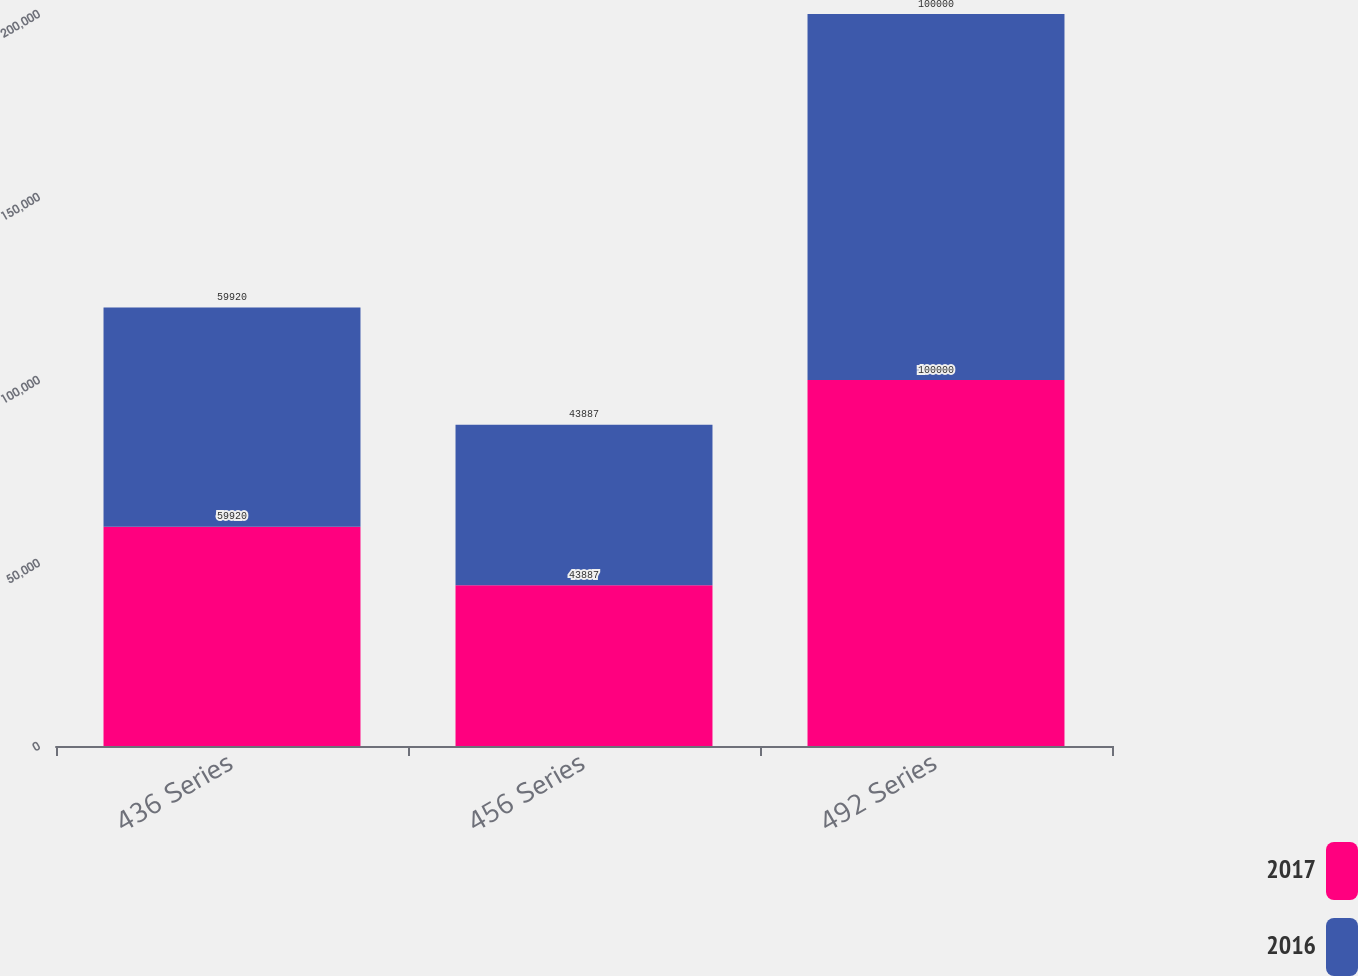Convert chart. <chart><loc_0><loc_0><loc_500><loc_500><stacked_bar_chart><ecel><fcel>436 Series<fcel>456 Series<fcel>492 Series<nl><fcel>2017<fcel>59920<fcel>43887<fcel>100000<nl><fcel>2016<fcel>59920<fcel>43887<fcel>100000<nl></chart> 